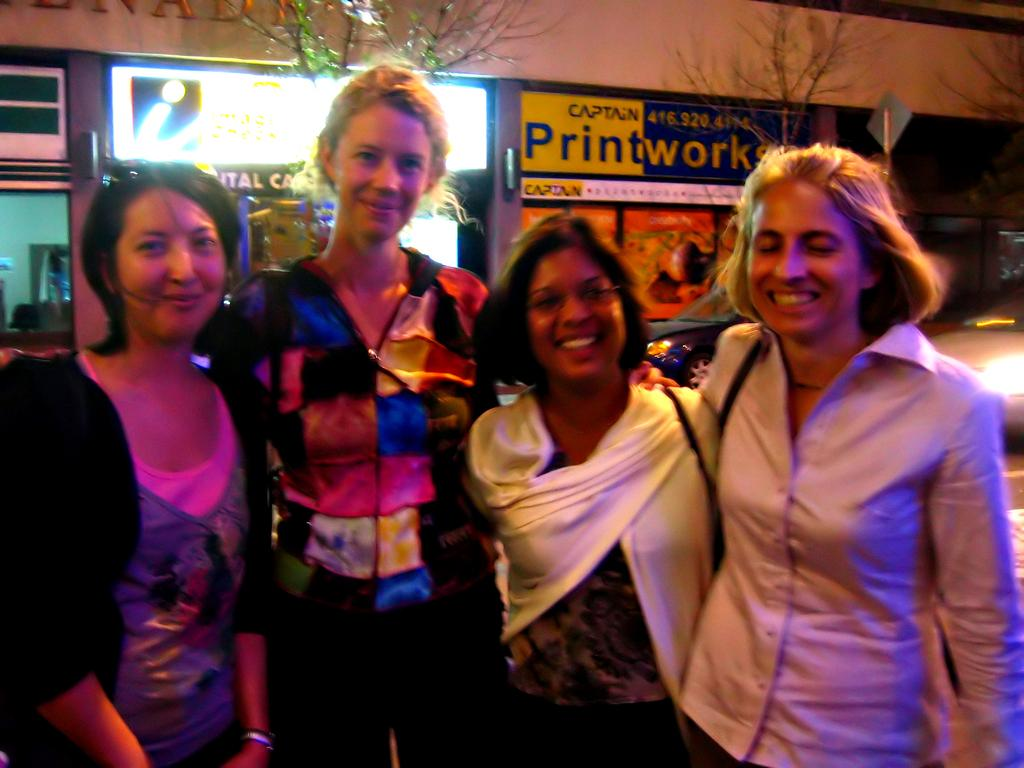What is happening in the image? There are people standing in the image. Can you describe the background of the image? There are boards attached to a wall in the background of the image. What type of hearing is taking place in the image? There is no hearing present in the image; it simply shows people standing and a wall with boards in the background. 